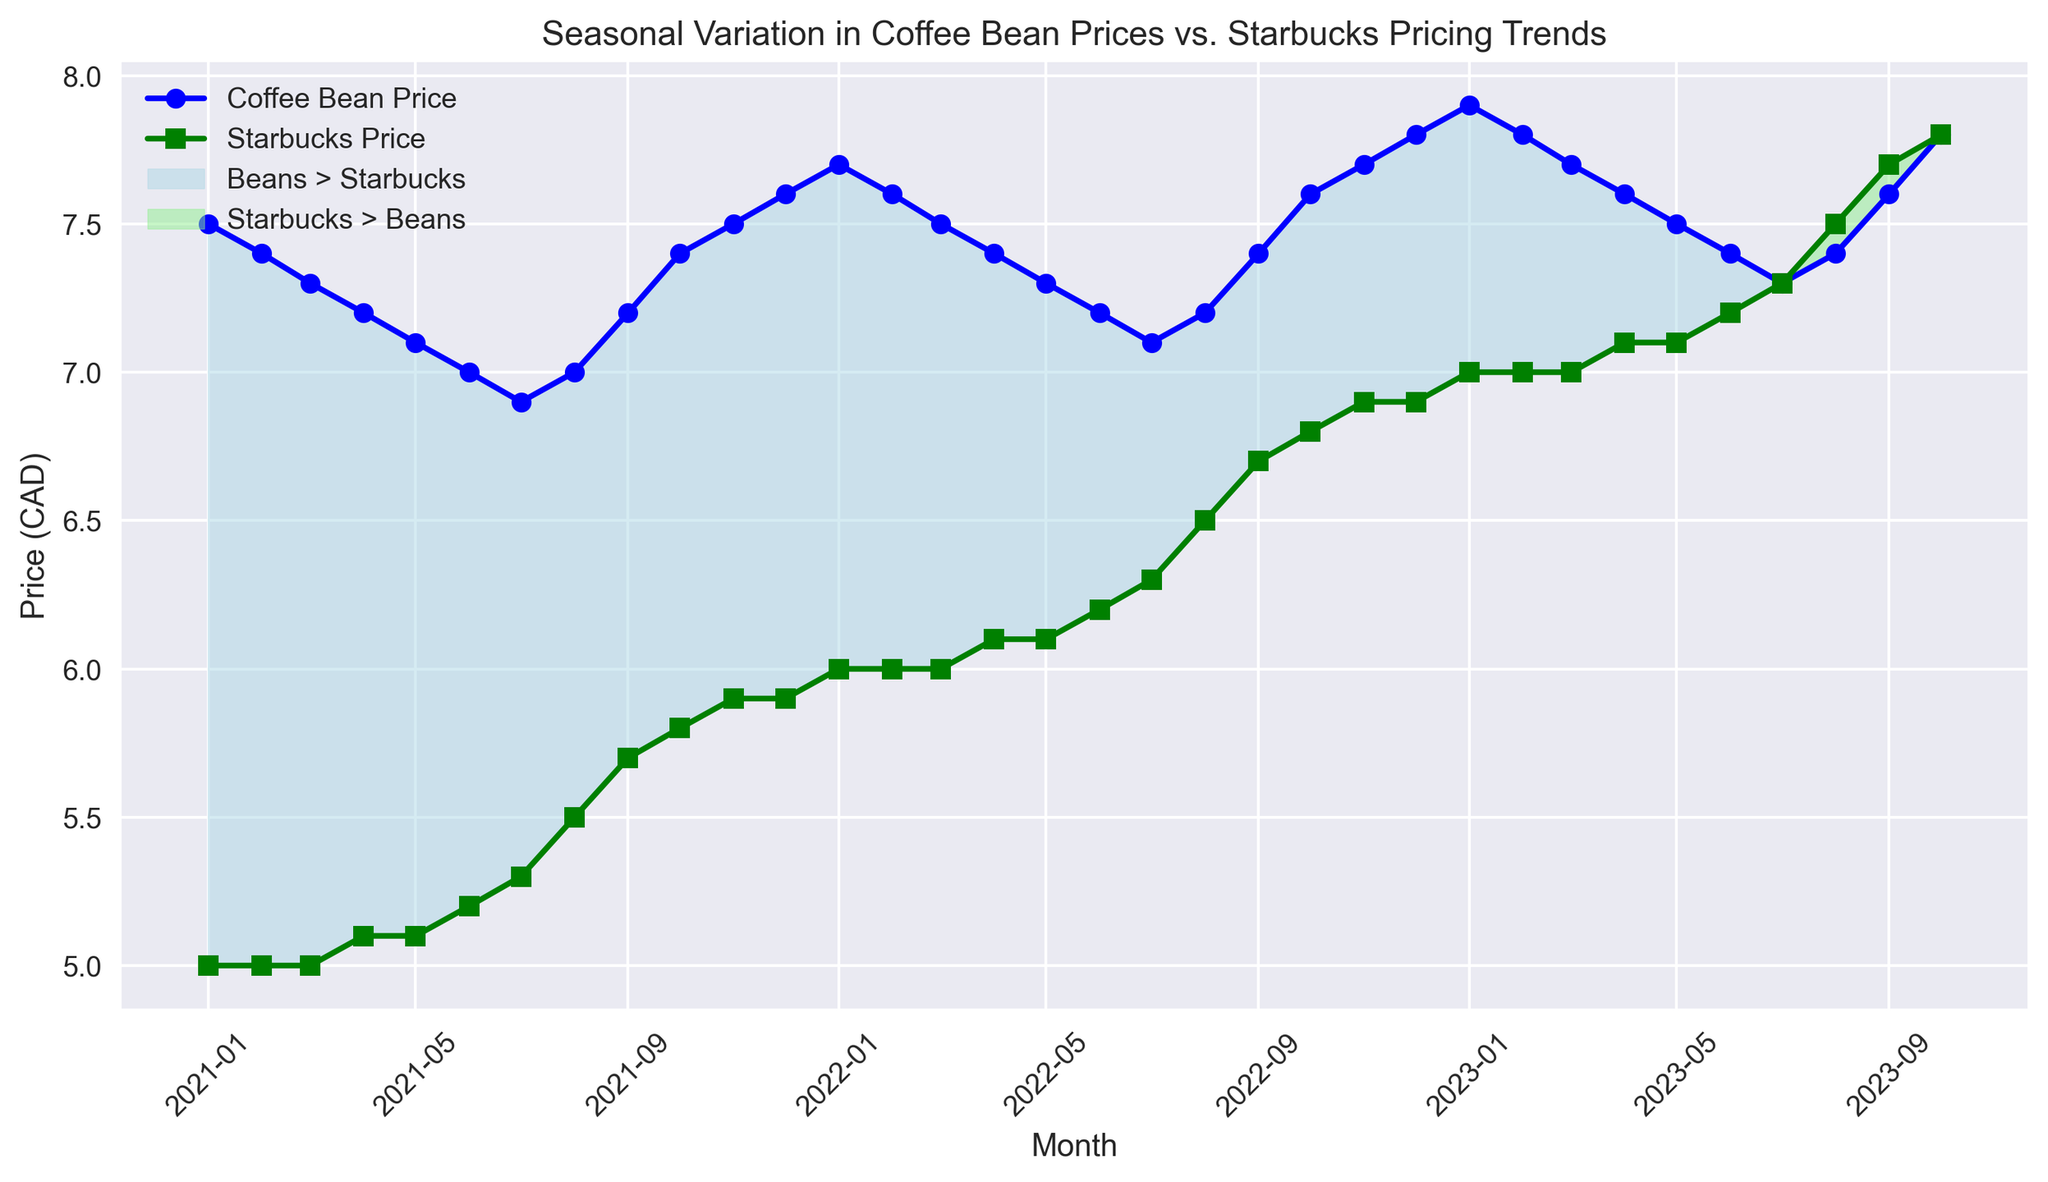How do the coffee bean prices compare to Starbucks prices in January 2021? To compare the prices, look at the data points for January 2021. The coffee bean price is $7.50, while the Starbucks price is $5.00. Thus, coffee bean prices are higher in January 2021.
Answer: Coffee beans are higher In which months is the Starbucks price equal to the coffee bean price? To find the months where the prices are equal, look for overlapping data points in the plot. The only month where the prices are equal is in October 2023, where both prices reach $7.80.
Answer: October 2023 By how much do coffee bean prices fluctuate throughout the year? Identify the highest and lowest coffee bean prices within the year. In 2021, the lowest price is in July ($6.90) and the highest is in December ($7.60). The fluctuation is $7.60 - $6.90.
Answer: $0.70 During which months do Starbucks prices surpass coffee bean prices? Observe the areas marked in light green, indicating times when Starbucks prices exceed coffee bean prices. These months are July to December of every year in the dataset.
Answer: July to December each year What is the average price difference between coffee beans and Starbucks in 2022? Calculate the monthly differences, then find the average. The monthly differences are $1.70, $1.60, $1.50, $1.30, $1.20, $1.00, $0.80, $0.70, $0.70, $0.80, $0.80, $0.90. Summing these differences, we get $13.00. Divided by 12 months, the average difference is $13.00/12.
Answer: $1.08 Which month shows the highest coffee bean price, and what is that price? Locate the highest point on the coffee bean price line. The highest price is in October 2023, at $7.80.
Answer: October 2023, $7.80 How does the trend of Starbucks prices change over the three years? Look at the overall trend line for Starbucks prices from January 2021 to October 2023. The prices steadily increase from $5.00 to $7.80 over this period.
Answer: Steady increase What is the price difference between Starbucks and coffee beans in September 2023? Refer to the plot for prices in September 2023. The coffee bean price is $7.60, and the Starbucks price is $7.70. The difference is $7.70 - $7.60.
Answer: $0.10 In which month of 2021 does the coffee bean price and Starbucks price difference start to decrease? Examine the plot around mid-2021. The difference starts to decrease around June 2021 when the coffee bean price continues to drop while Starbucks price starts to increase.
Answer: June 2021 